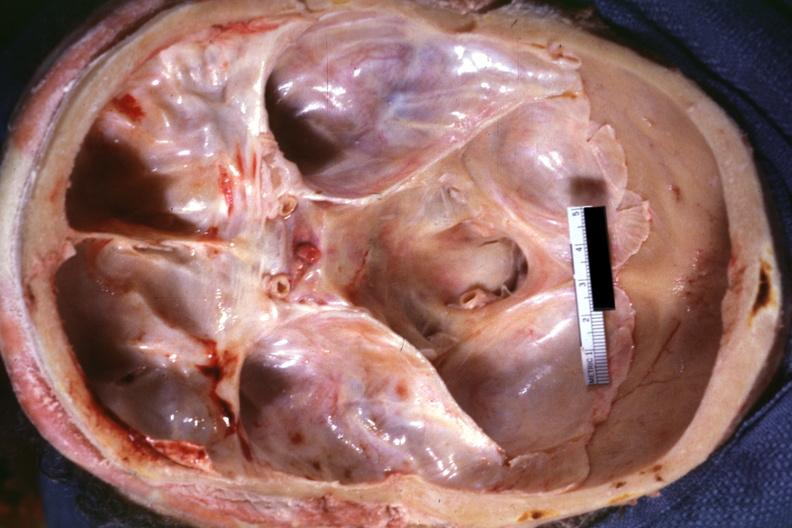why does this image show view into foramen magnum marked narrowing?
Answer the question using a single word or phrase. Due to subluxation odontoid process second cervical vertebra 